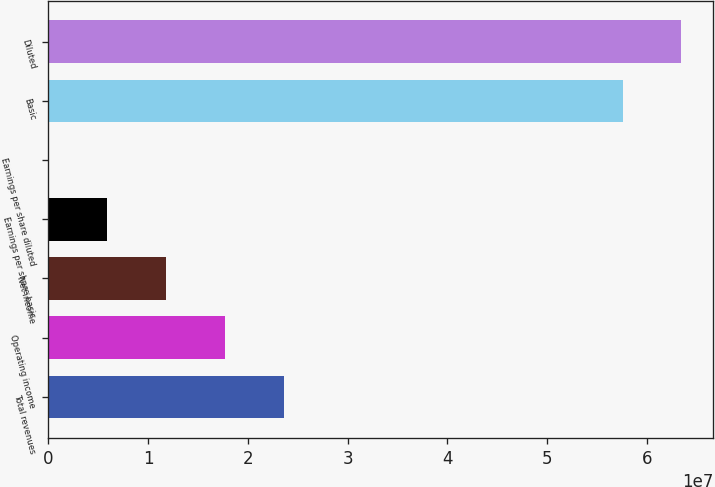Convert chart to OTSL. <chart><loc_0><loc_0><loc_500><loc_500><bar_chart><fcel>Total revenues<fcel>Operating income<fcel>Net income<fcel>Earnings per share basic<fcel>Earnings per share diluted<fcel>Basic<fcel>Diluted<nl><fcel>2.35872e+07<fcel>1.76904e+07<fcel>1.17936e+07<fcel>5.89681e+06<fcel>0.74<fcel>5.75502e+07<fcel>6.3447e+07<nl></chart> 